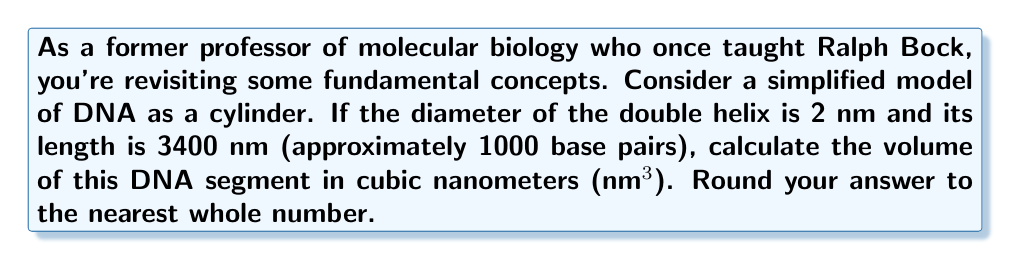What is the answer to this math problem? Let's approach this step-by-step:

1) The DNA double helix is modeled as a cylinder. The volume of a cylinder is given by the formula:

   $$V = \pi r^2 h$$

   where $V$ is volume, $r$ is the radius of the base, and $h$ is the height (length) of the cylinder.

2) We're given the diameter of 2 nm. The radius is half of this:

   $$r = \frac{2 \text{ nm}}{2} = 1 \text{ nm}$$

3) The length (height) of the cylinder is given as 3400 nm.

4) Let's substitute these values into our formula:

   $$V = \pi (1 \text{ nm})^2 (3400 \text{ nm})$$

5) Simplify:

   $$V = 3400\pi \text{ nm}^3$$

6) Calculate:

   $$V \approx 10681.4 \text{ nm}^3$$

7) Rounding to the nearest whole number:

   $$V \approx 10681 \text{ nm}^3$$
Answer: $10681 \text{ nm}^3$ 